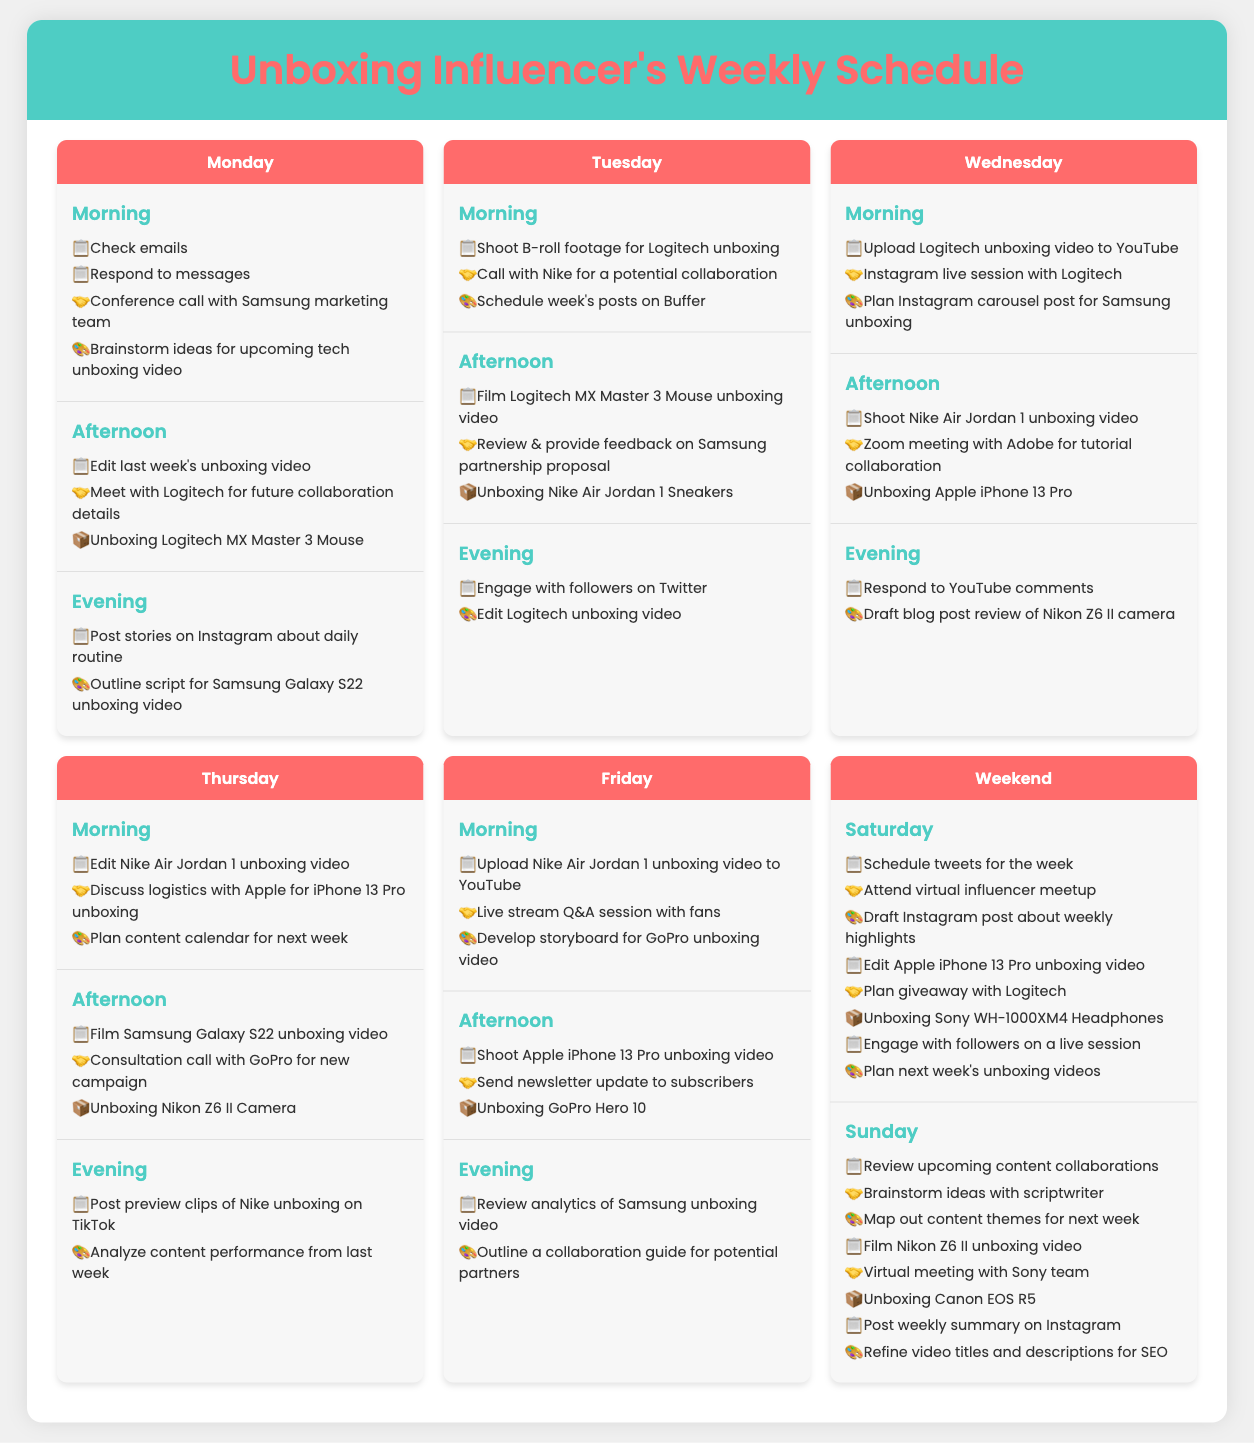What is scheduled for Monday afternoon? The schedule notes that the tasks for Monday afternoon include editing the last week's unboxing video, meeting with Logitech for future collaboration details, and unboxing the Logitech MX Master 3 Mouse.
Answer: Edit last week's unboxing video, Meet with Logitech, Unboxing Logitech MX Master 3 Mouse Which brand is involved in collaboration discussions on Tuesday? The schedule indicates that on Tuesday, there is a call with Nike for a potential collaboration.
Answer: Nike What is the upcoming unboxing video for Wednesday afternoon? Wednesday's afternoon schedule mentions shooting the Nike Air Jordan 1 unboxing video.
Answer: Unboxing Apple iPhone 13 Pro How many tasks are listed for Saturday? The Saturday schedule includes eight tasks related to scheduling tweets, attending a virtual influencer meetup, and others.
Answer: 8 What video is planned for Saturday evening? On Saturday, the evening tasks include planning next week's unboxing videos.
Answer: Unboxing Sony WH-1000XM4 Headphones What is the influencer's activity during the Monday morning slot? The Monday morning schedule includes checking emails, responding to messages, and a conference call with the Samsung marketing team.
Answer: Check emails, Respond to messages, Conference call with Samsung marketing team What type of call is scheduled with Adobe on Wednesday? On Wednesday afternoon, there is a Zoom meeting with Adobe for a tutorial collaboration.
Answer: Zoom meeting How does the influencer plan to engage with followers on Friday? On Friday morning, there is a live stream Q&A session scheduled with fans.
Answer: Live stream Q&A session 